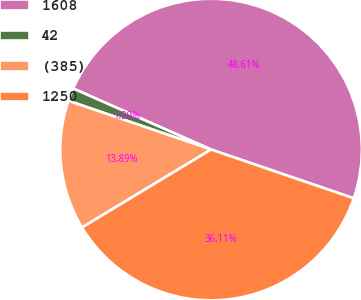Convert chart to OTSL. <chart><loc_0><loc_0><loc_500><loc_500><pie_chart><fcel>1608<fcel>42<fcel>(385)<fcel>1250<nl><fcel>48.61%<fcel>1.39%<fcel>13.89%<fcel>36.11%<nl></chart> 